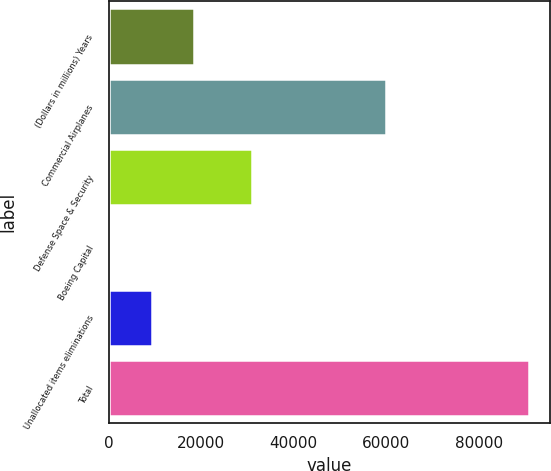Convert chart to OTSL. <chart><loc_0><loc_0><loc_500><loc_500><bar_chart><fcel>(Dollars in millions) Years<fcel>Commercial Airplanes<fcel>Defense Space & Security<fcel>Boeing Capital<fcel>Unallocated items eliminations<fcel>Total<nl><fcel>18485.2<fcel>59990<fcel>30881<fcel>416<fcel>9450.6<fcel>90762<nl></chart> 